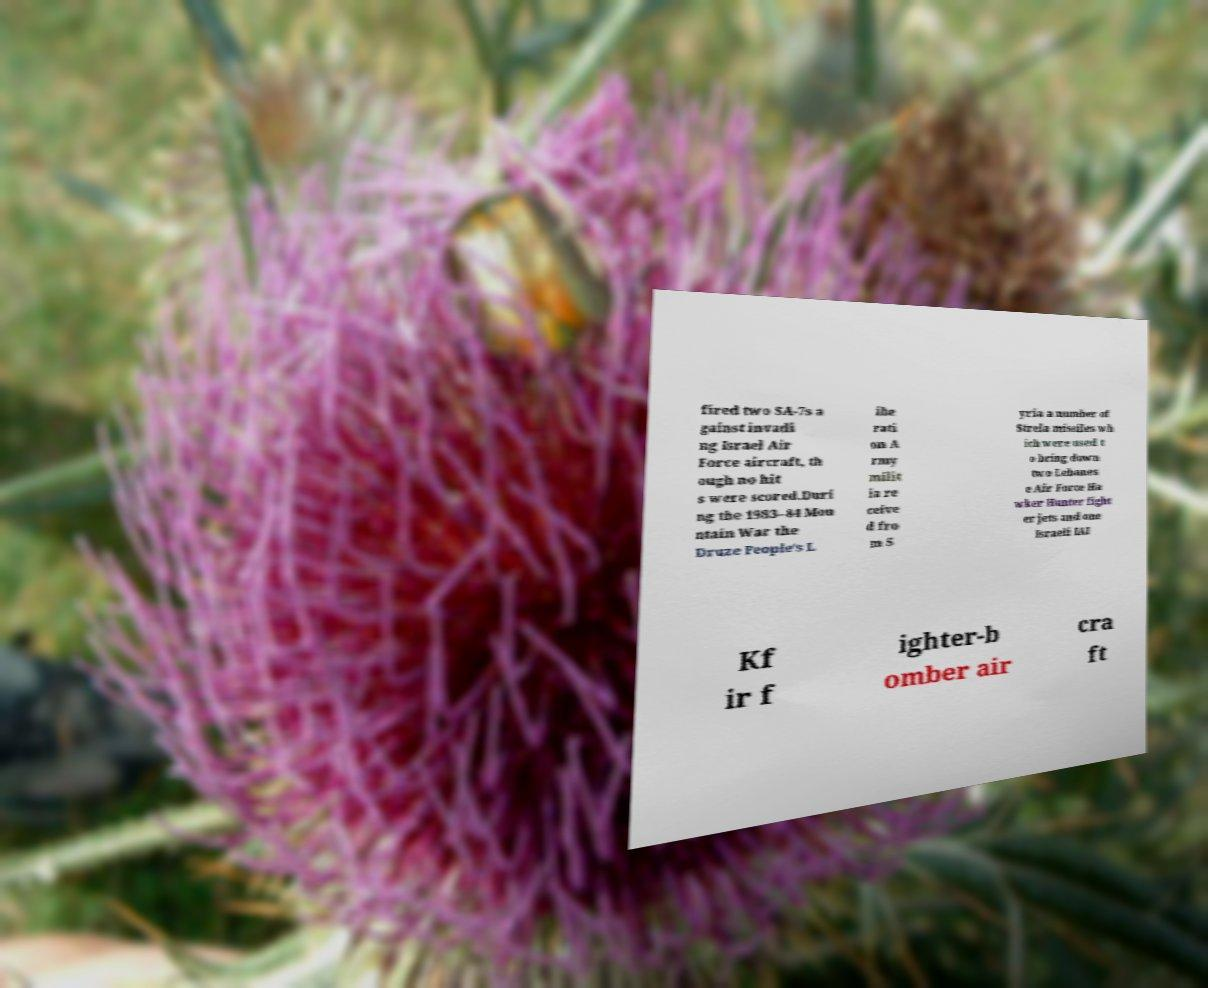Could you extract and type out the text from this image? fired two SA-7s a gainst invadi ng Israel Air Force aircraft, th ough no hit s were scored.Duri ng the 1983–84 Mou ntain War the Druze People's L ibe rati on A rmy milit ia re ceive d fro m S yria a number of Strela missiles wh ich were used t o bring down two Lebanes e Air Force Ha wker Hunter fight er jets and one Israeli IAI Kf ir f ighter-b omber air cra ft 